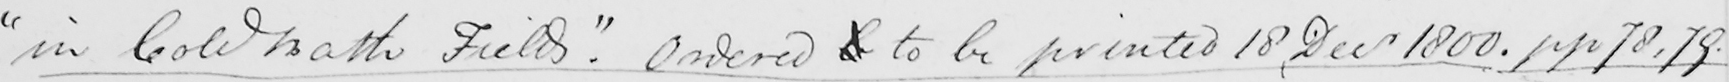Can you read and transcribe this handwriting? " in Cold Bath Fields "  . Ordered b to be printed 18 , Decr 1800 . pp 78 , 79 . 